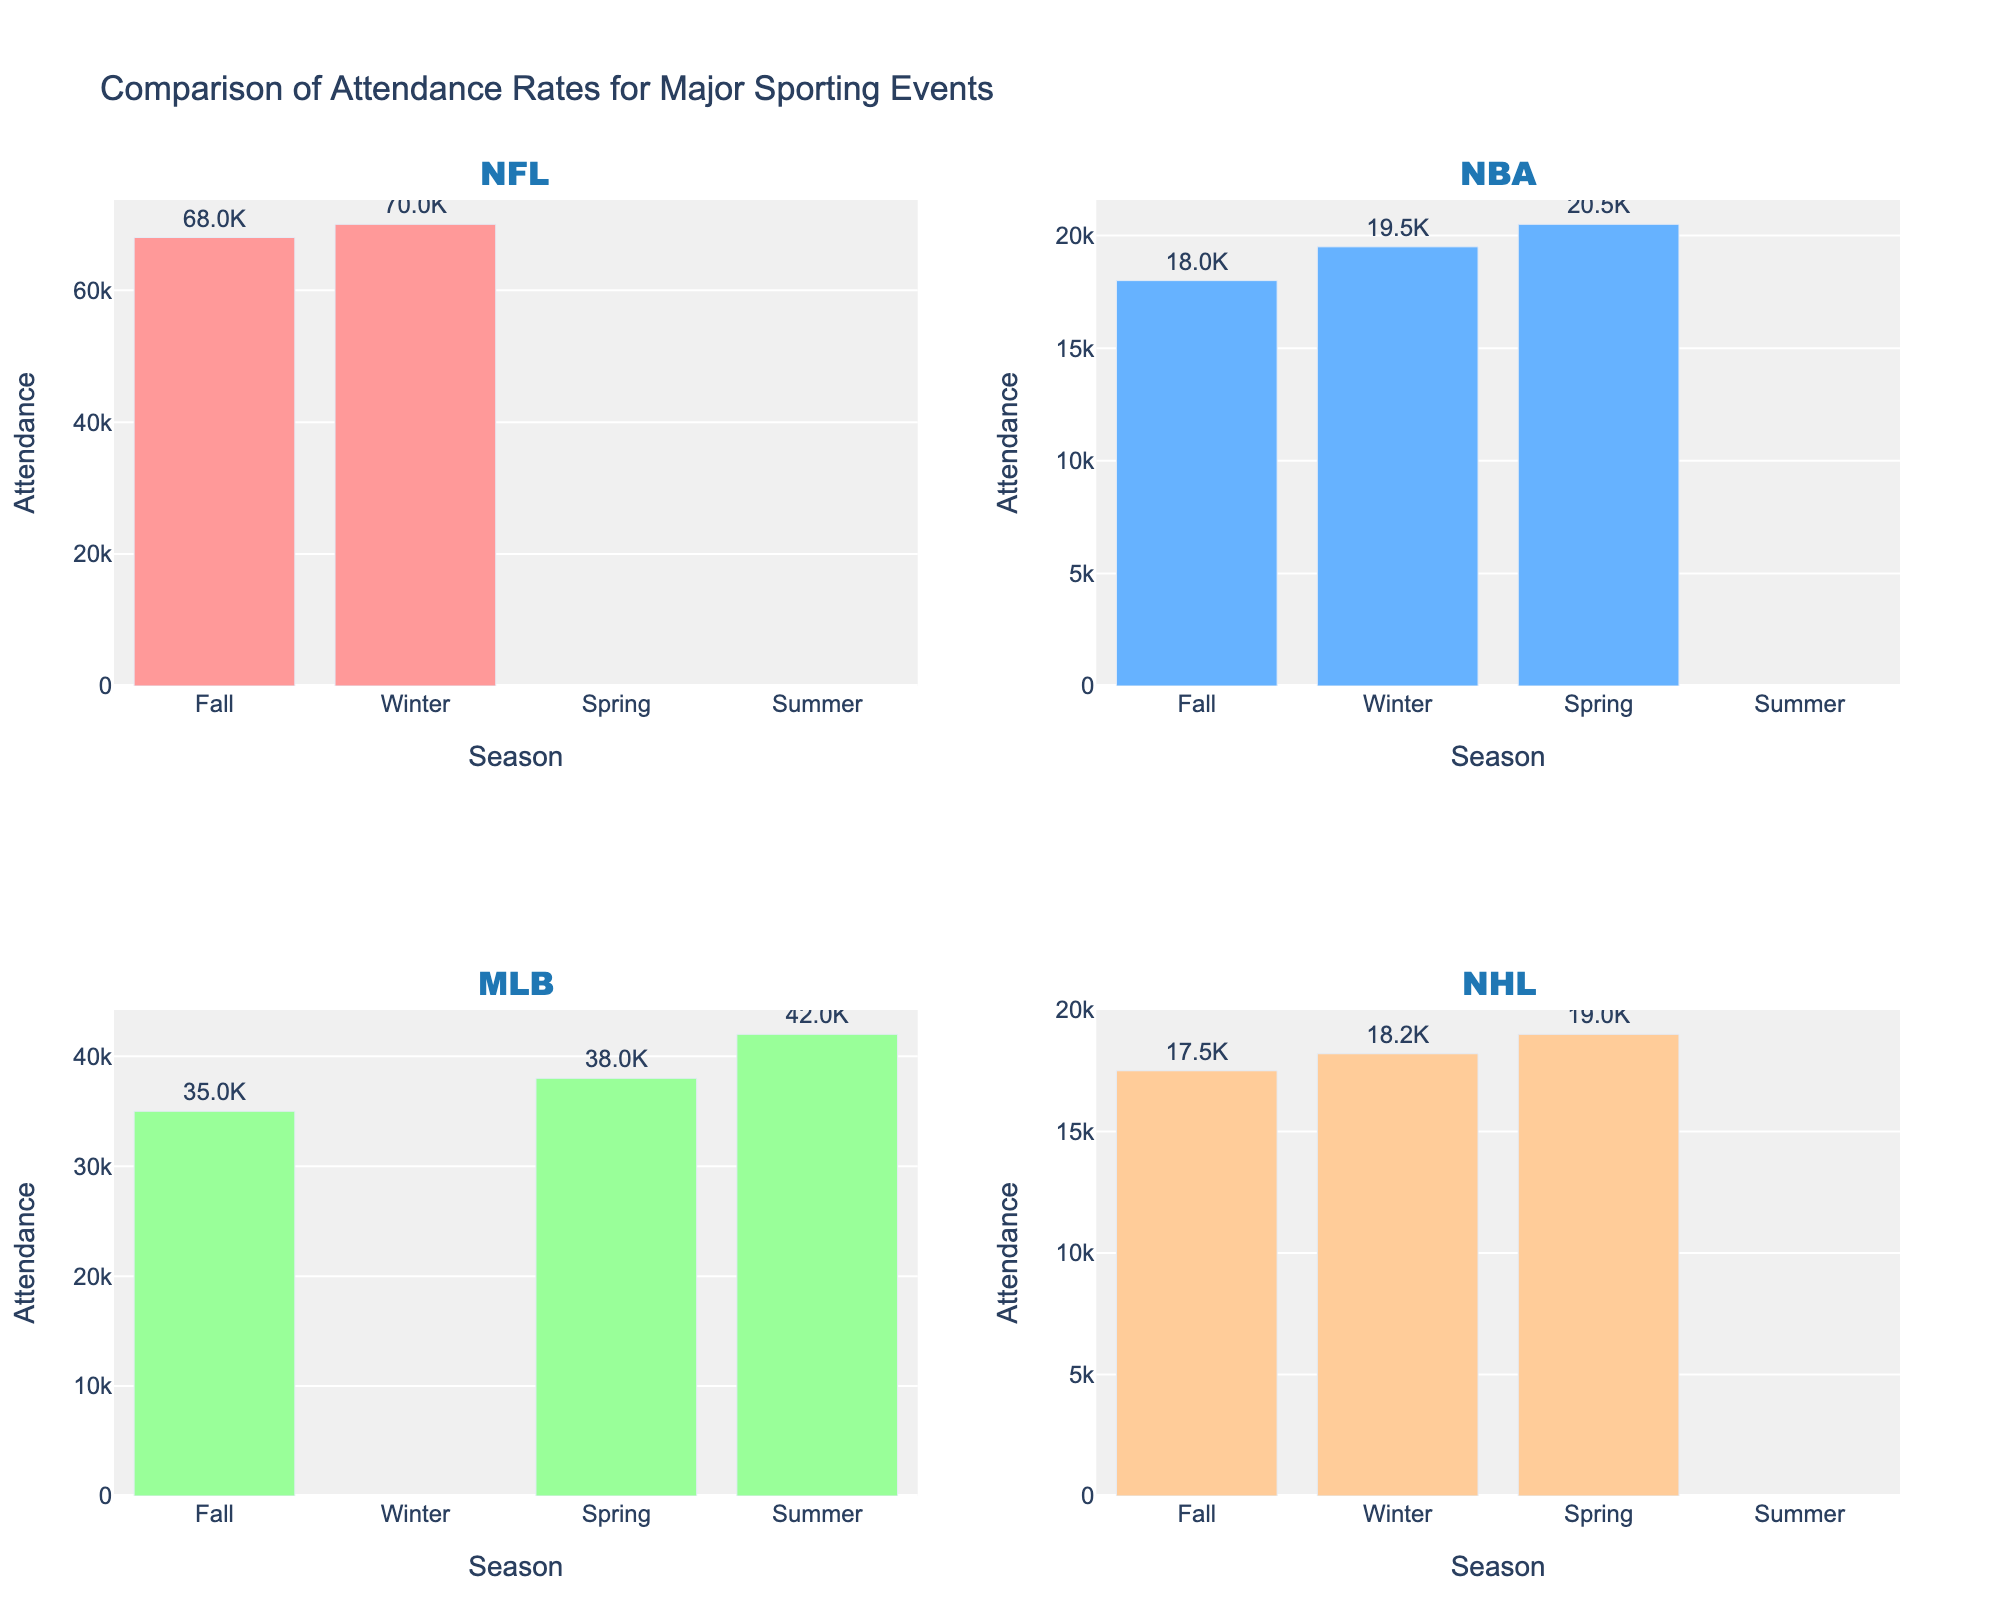What's the title of the figure? Look at the text at the top of the figure, which provides the overall topic of the plot.
Answer: Comparison of Attendance Rates for Major Sporting Events What are the leagues included in the subplots? Look at the subplot titles, each of which corresponds to a different league.
Answer: NFL, NBA, MLB, NHL Which league has the highest attendance in the Fall season? Look at the bar heights for each league in the Fall season, and compare them.
Answer: NFL How many seasons show attendance for the NBA? Observe the NBA plot and count the number of bars representing seasons.
Answer: 4 What season has the highest overall attendance across all leagues? Identify the highest bar in each subplot, then compare these values across seasons to determine the highest across the entire chart.
Answer: Winter Which league does not have attendance data for the Summer season? Look at each subplot and identify which leagues are missing bars for the Summer season.
Answer: NFL, NBA, NHL What is the difference in attendance between the NFL in the Fall season and the NBA in the Winter season? Observe the attendance values in the respective season bars for NFL Fall and NBA Winter, then subtract the NBA Winter value from the NFL Fall value. Calculation: 68000 - 19500 = 48500
Answer: 48500 Is the MLB attendance higher in the Spring or Summer season? Compare the height of the bars for MLB in Spring and Summer seasons.
Answer: Summer What is the average attendance for the NHL across all available seasons? Add the NHL attendance values across Fall, Winter, and Spring, then divide by the number of those values to get the average. Calculation: (17500 + 18200 + 19000)/3 = 18233.33
Answer: 18233.33 Which season has the highest attendance for the NBA? Identify the tallest bar in the NBA subplot and note the corresponding season.
Answer: Spring 